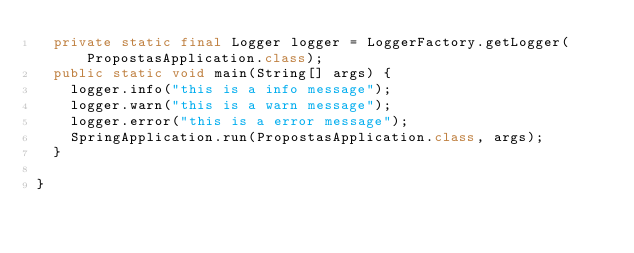<code> <loc_0><loc_0><loc_500><loc_500><_Java_>	private static final Logger logger = LoggerFactory.getLogger(PropostasApplication.class);
	public static void main(String[] args) {
		logger.info("this is a info message");
		logger.warn("this is a warn message");
		logger.error("this is a error message");
		SpringApplication.run(PropostasApplication.class, args);
	}

}
</code> 